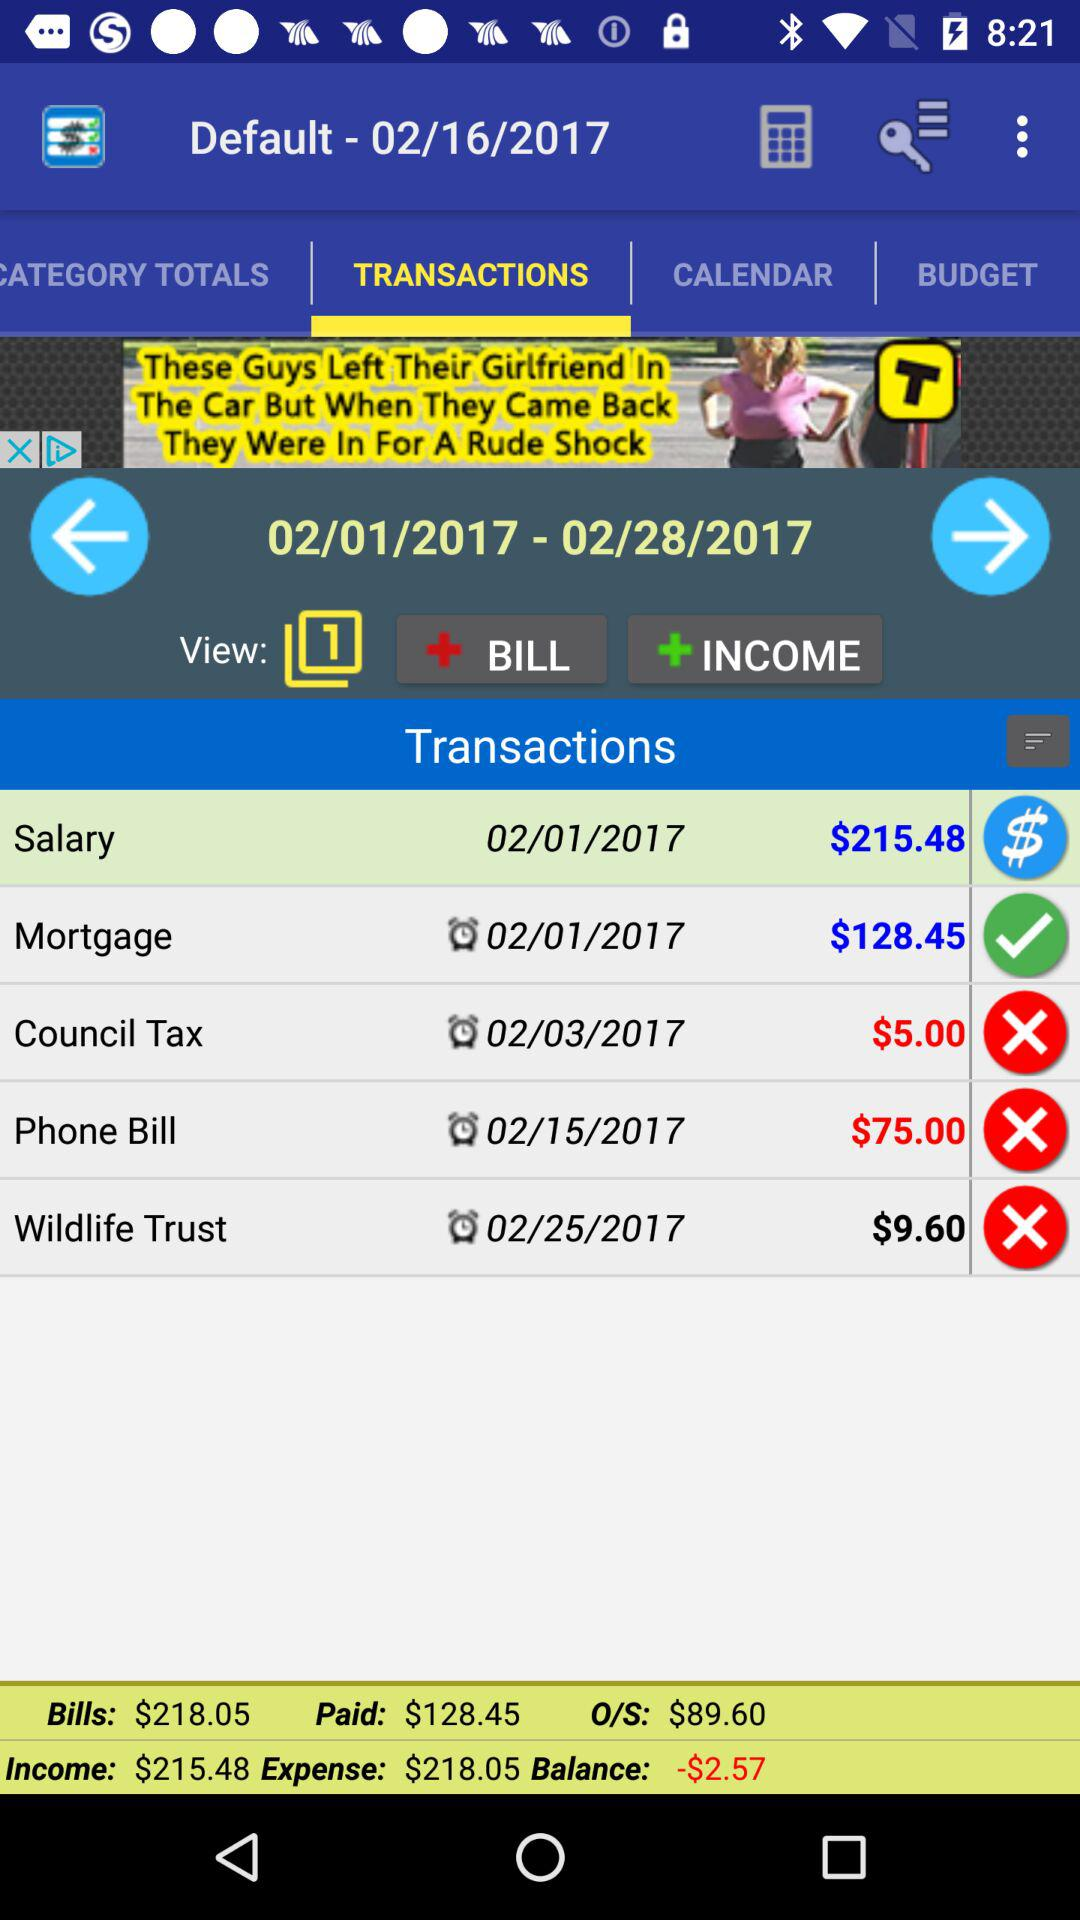What is the paid amount? The paid amount is $128.45. 